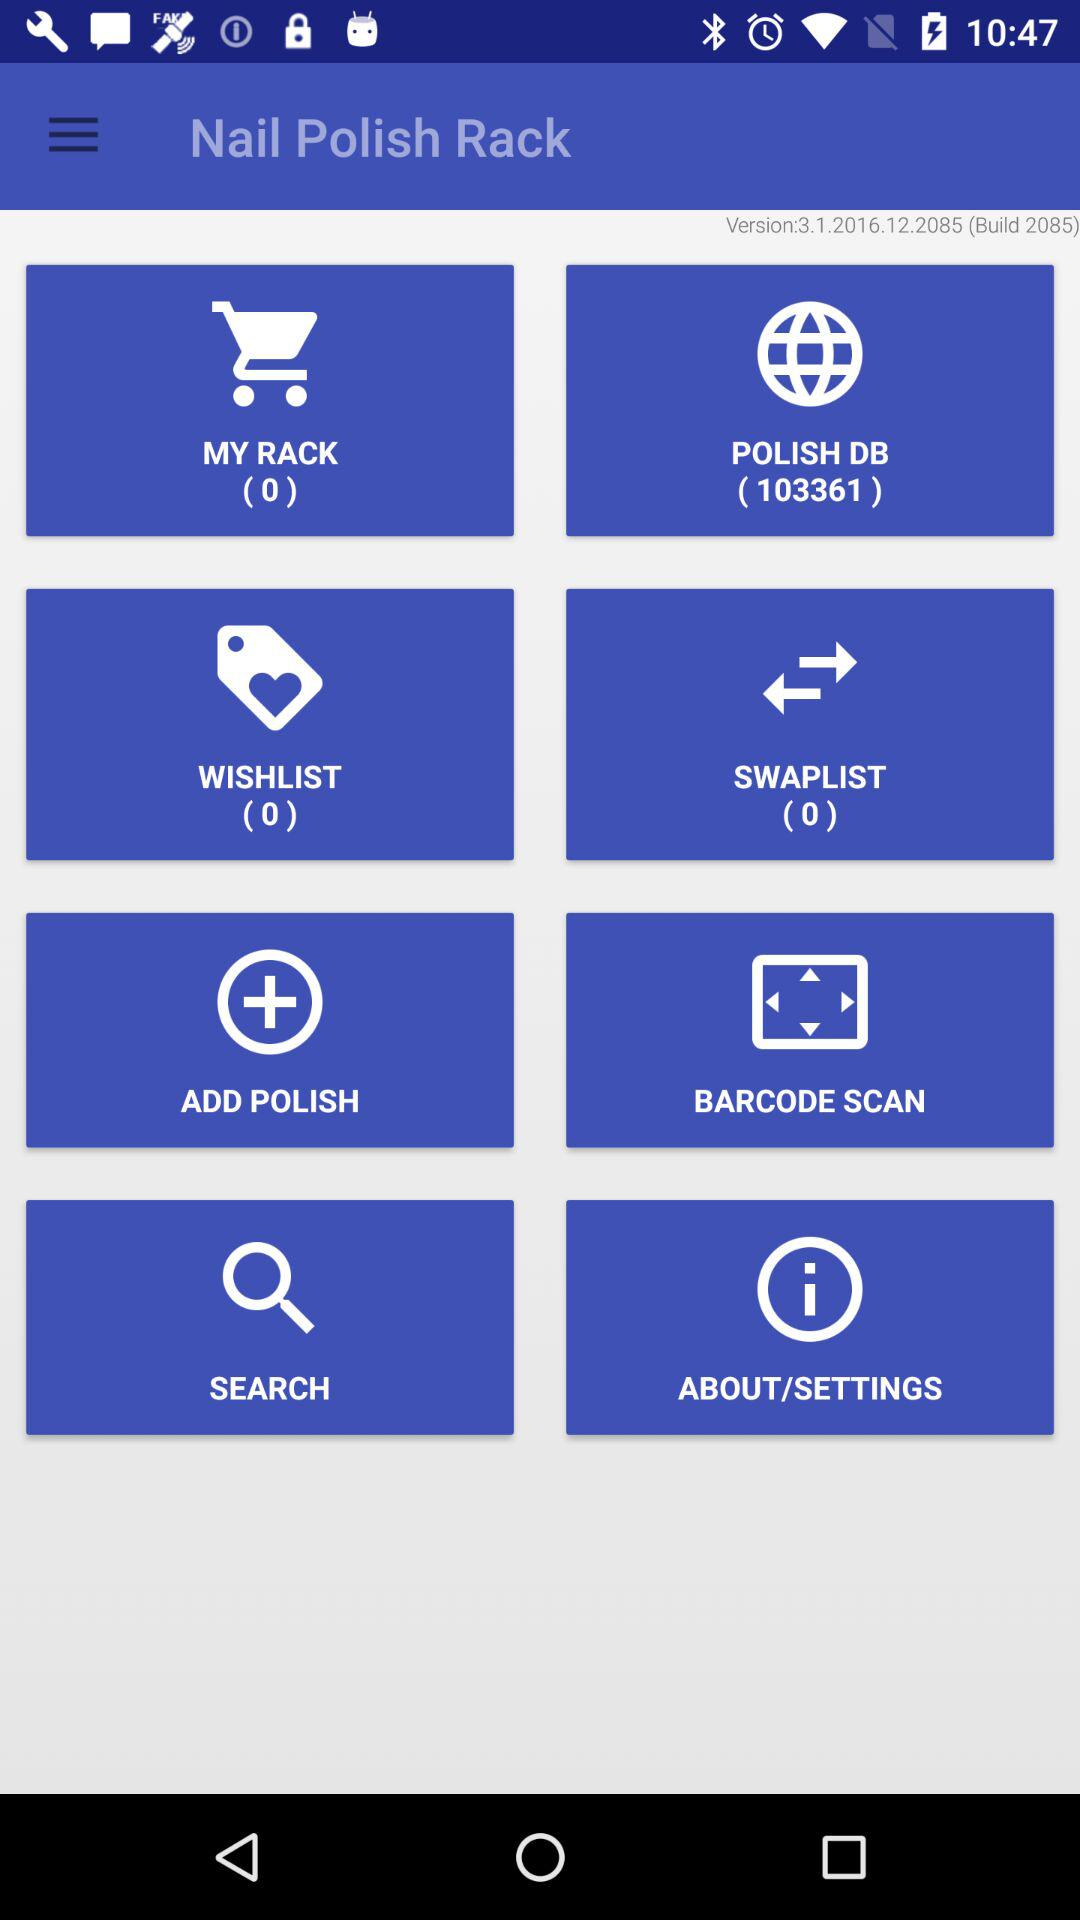What is the number of items in "WISHLIST"? The number of items is 0. 